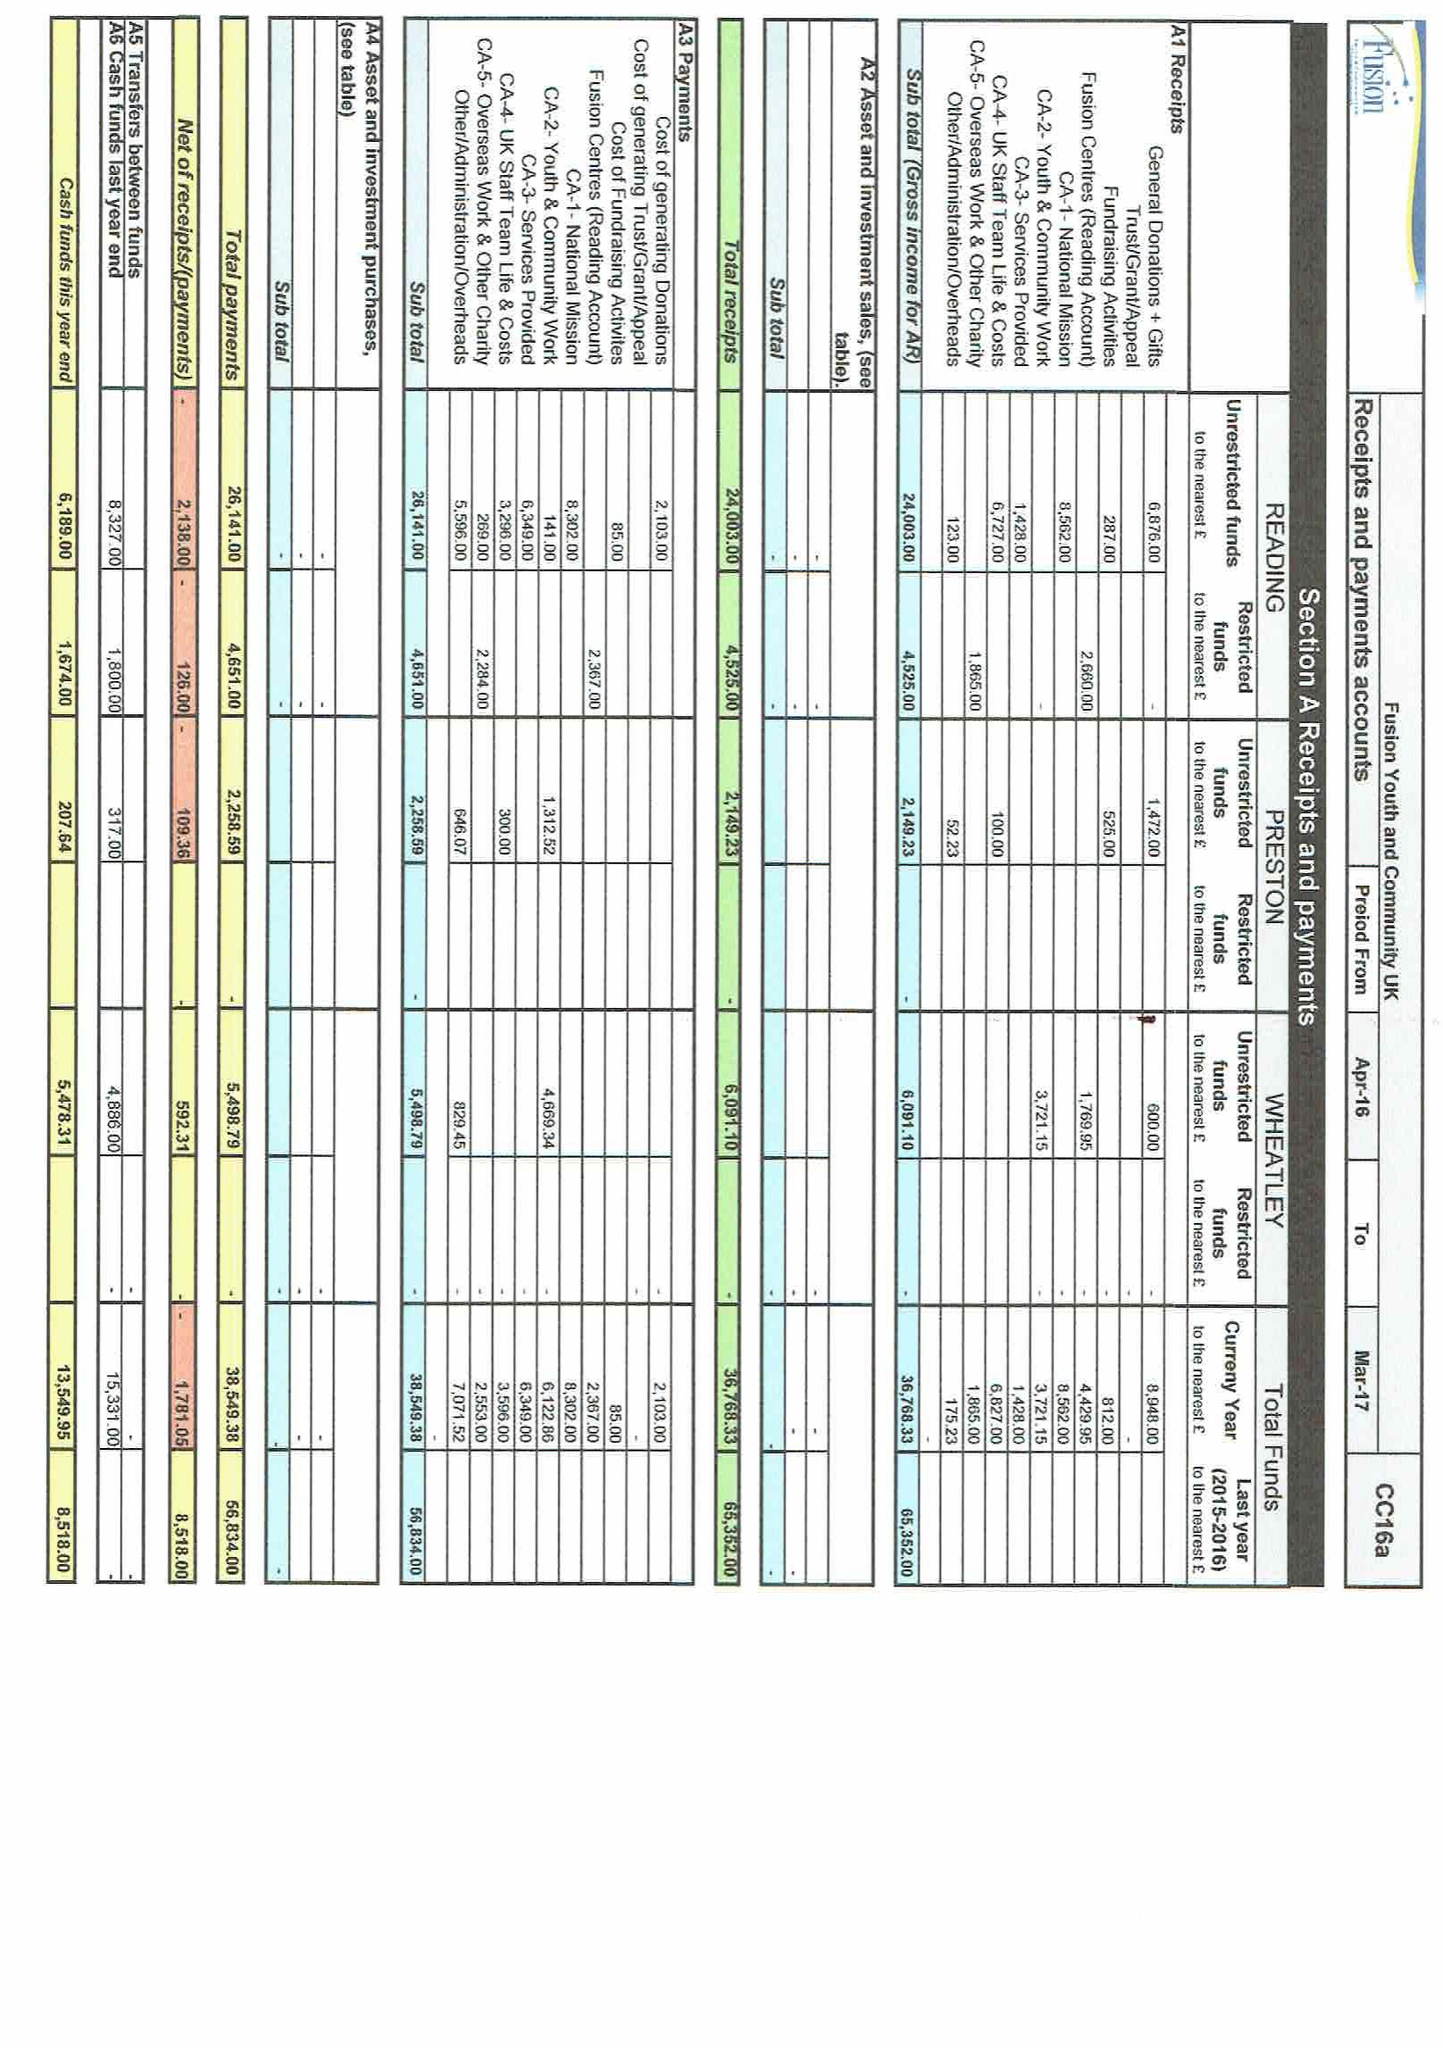What is the value for the spending_annually_in_british_pounds?
Answer the question using a single word or phrase. 38549.00 